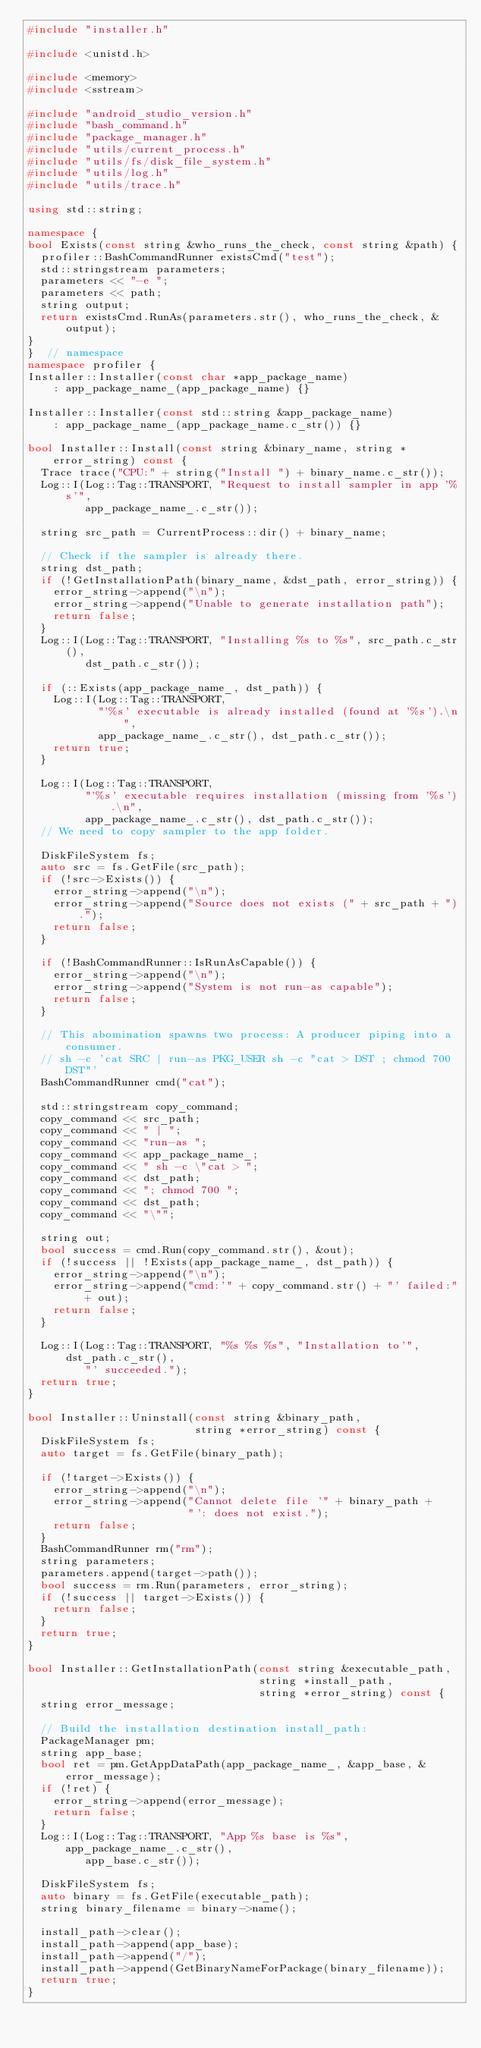Convert code to text. <code><loc_0><loc_0><loc_500><loc_500><_C++_>#include "installer.h"

#include <unistd.h>

#include <memory>
#include <sstream>

#include "android_studio_version.h"
#include "bash_command.h"
#include "package_manager.h"
#include "utils/current_process.h"
#include "utils/fs/disk_file_system.h"
#include "utils/log.h"
#include "utils/trace.h"

using std::string;

namespace {
bool Exists(const string &who_runs_the_check, const string &path) {
  profiler::BashCommandRunner existsCmd("test");
  std::stringstream parameters;
  parameters << "-e ";
  parameters << path;
  string output;
  return existsCmd.RunAs(parameters.str(), who_runs_the_check, &output);
}
}  // namespace
namespace profiler {
Installer::Installer(const char *app_package_name)
    : app_package_name_(app_package_name) {}

Installer::Installer(const std::string &app_package_name)
    : app_package_name_(app_package_name.c_str()) {}

bool Installer::Install(const string &binary_name, string *error_string) const {
  Trace trace("CPU:" + string("Install ") + binary_name.c_str());
  Log::I(Log::Tag::TRANSPORT, "Request to install sampler in app '%s'",
         app_package_name_.c_str());

  string src_path = CurrentProcess::dir() + binary_name;

  // Check if the sampler is already there.
  string dst_path;
  if (!GetInstallationPath(binary_name, &dst_path, error_string)) {
    error_string->append("\n");
    error_string->append("Unable to generate installation path");
    return false;
  }
  Log::I(Log::Tag::TRANSPORT, "Installing %s to %s", src_path.c_str(),
         dst_path.c_str());

  if (::Exists(app_package_name_, dst_path)) {
    Log::I(Log::Tag::TRANSPORT,
           "'%s' executable is already installed (found at '%s').\n",
           app_package_name_.c_str(), dst_path.c_str());
    return true;
  }

  Log::I(Log::Tag::TRANSPORT,
         "'%s' executable requires installation (missing from '%s').\n",
         app_package_name_.c_str(), dst_path.c_str());
  // We need to copy sampler to the app folder.

  DiskFileSystem fs;
  auto src = fs.GetFile(src_path);
  if (!src->Exists()) {
    error_string->append("\n");
    error_string->append("Source does not exists (" + src_path + ").");
    return false;
  }

  if (!BashCommandRunner::IsRunAsCapable()) {
    error_string->append("\n");
    error_string->append("System is not run-as capable");
    return false;
  }

  // This abomination spawns two process: A producer piping into a consumer.
  // sh -c 'cat SRC | run-as PKG_USER sh -c "cat > DST ; chmod 700 DST"'
  BashCommandRunner cmd("cat");

  std::stringstream copy_command;
  copy_command << src_path;
  copy_command << " | ";
  copy_command << "run-as ";
  copy_command << app_package_name_;
  copy_command << " sh -c \"cat > ";
  copy_command << dst_path;
  copy_command << "; chmod 700 ";
  copy_command << dst_path;
  copy_command << "\"";

  string out;
  bool success = cmd.Run(copy_command.str(), &out);
  if (!success || !Exists(app_package_name_, dst_path)) {
    error_string->append("\n");
    error_string->append("cmd:'" + copy_command.str() + "' failed:" + out);
    return false;
  }

  Log::I(Log::Tag::TRANSPORT, "%s %s %s", "Installation to'", dst_path.c_str(),
         "' succeeded.");
  return true;
}

bool Installer::Uninstall(const string &binary_path,
                          string *error_string) const {
  DiskFileSystem fs;
  auto target = fs.GetFile(binary_path);

  if (!target->Exists()) {
    error_string->append("\n");
    error_string->append("Cannot delete file '" + binary_path +
                         "': does not exist.");
    return false;
  }
  BashCommandRunner rm("rm");
  string parameters;
  parameters.append(target->path());
  bool success = rm.Run(parameters, error_string);
  if (!success || target->Exists()) {
    return false;
  }
  return true;
}

bool Installer::GetInstallationPath(const string &executable_path,
                                    string *install_path,
                                    string *error_string) const {
  string error_message;

  // Build the installation destination install_path:
  PackageManager pm;
  string app_base;
  bool ret = pm.GetAppDataPath(app_package_name_, &app_base, &error_message);
  if (!ret) {
    error_string->append(error_message);
    return false;
  }
  Log::I(Log::Tag::TRANSPORT, "App %s base is %s", app_package_name_.c_str(),
         app_base.c_str());

  DiskFileSystem fs;
  auto binary = fs.GetFile(executable_path);
  string binary_filename = binary->name();

  install_path->clear();
  install_path->append(app_base);
  install_path->append("/");
  install_path->append(GetBinaryNameForPackage(binary_filename));
  return true;
}
</code> 